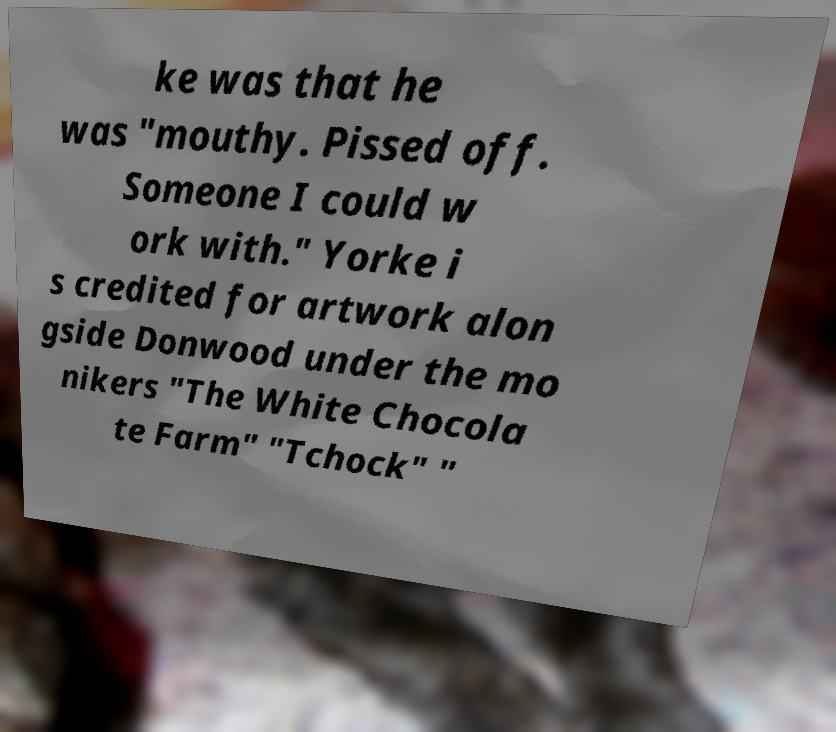I need the written content from this picture converted into text. Can you do that? ke was that he was "mouthy. Pissed off. Someone I could w ork with." Yorke i s credited for artwork alon gside Donwood under the mo nikers "The White Chocola te Farm" "Tchock" " 